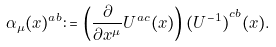Convert formula to latex. <formula><loc_0><loc_0><loc_500><loc_500>\alpha _ { \mu } ( x ) ^ { a b } & \colon = \left ( \frac { \partial } { \partial x ^ { \mu } } U ^ { a c } ( x ) \right ) { ( U ^ { - 1 } ) } ^ { c b } ( x ) .</formula> 